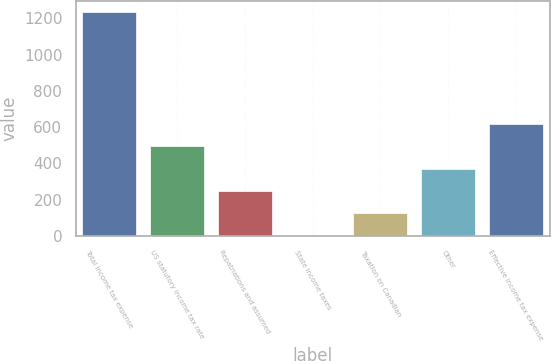<chart> <loc_0><loc_0><loc_500><loc_500><bar_chart><fcel>Total income tax expense<fcel>US statutory income tax rate<fcel>Repatriations and assumed<fcel>State income taxes<fcel>Taxation on Canadian<fcel>Other<fcel>Effective income tax expense<nl><fcel>1235<fcel>494.6<fcel>247.8<fcel>1<fcel>124.4<fcel>371.2<fcel>618<nl></chart> 